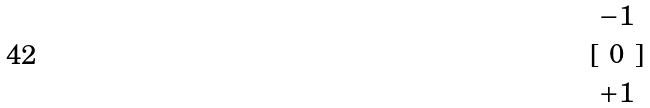<formula> <loc_0><loc_0><loc_500><loc_500>[ \begin{matrix} - 1 \\ 0 \\ + 1 \end{matrix} ]</formula> 